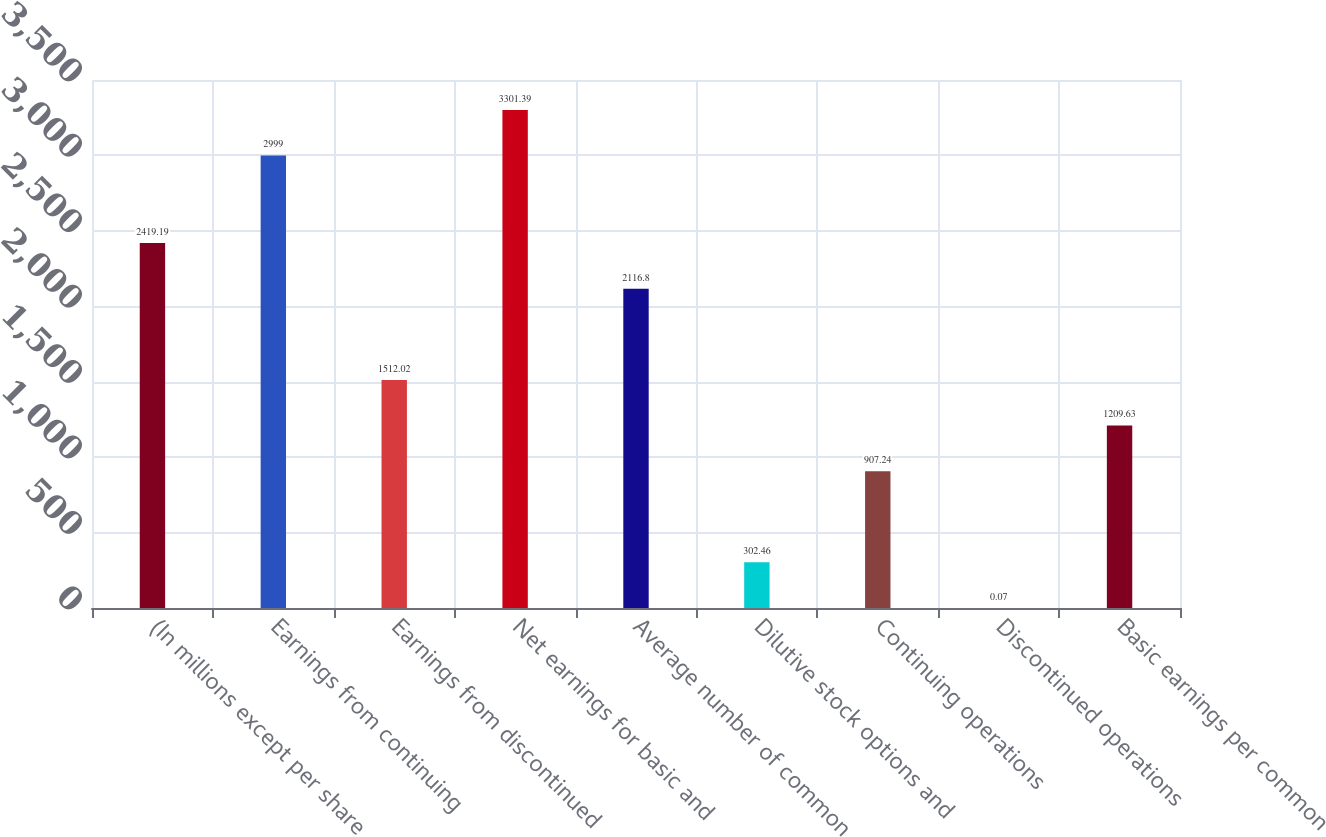Convert chart to OTSL. <chart><loc_0><loc_0><loc_500><loc_500><bar_chart><fcel>(In millions except per share<fcel>Earnings from continuing<fcel>Earnings from discontinued<fcel>Net earnings for basic and<fcel>Average number of common<fcel>Dilutive stock options and<fcel>Continuing operations<fcel>Discontinued operations<fcel>Basic earnings per common<nl><fcel>2419.19<fcel>2999<fcel>1512.02<fcel>3301.39<fcel>2116.8<fcel>302.46<fcel>907.24<fcel>0.07<fcel>1209.63<nl></chart> 